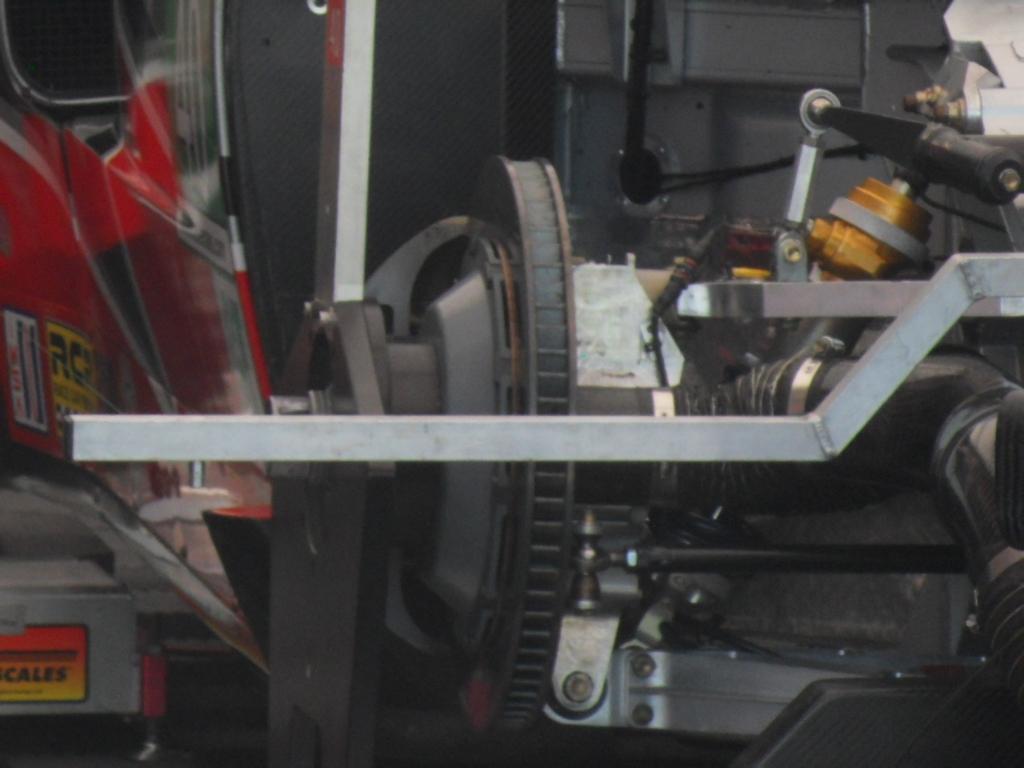In one or two sentences, can you explain what this image depicts? In this picture we can see rods, motor and metal objects. 